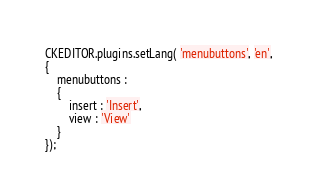<code> <loc_0><loc_0><loc_500><loc_500><_JavaScript_>
CKEDITOR.plugins.setLang( 'menubuttons', 'en',
{
	menubuttons :
	{
		insert : 'Insert',
		view : 'View'
	}
});
</code> 